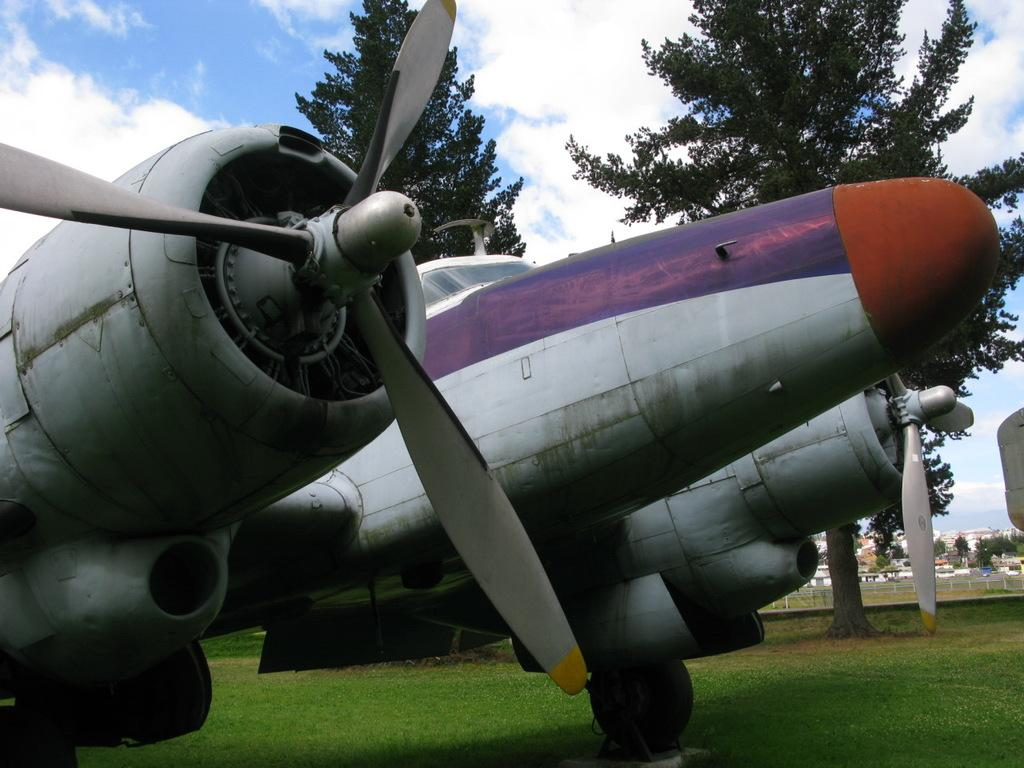What is the main subject of the image? The main subject of the image is a plane. What type of terrain is visible in the image? There is grass in the image, which suggests a grassy area. What other natural elements can be seen in the image? There are trees in the image. What is visible in the background of the image? There are buildings in the background of the image. What is visible at the top of the image? The sky is visible at the top of the image, and clouds are present in the sky. Can you tell me how the self is cooking in the image? There is no self or cooking activity present in the image. What type of look does the plane have in the image? The question is unclear, as planes do not have facial expressions or "looks." The image shows a plane, and its appearance can be described in terms of its size, color, and design. 